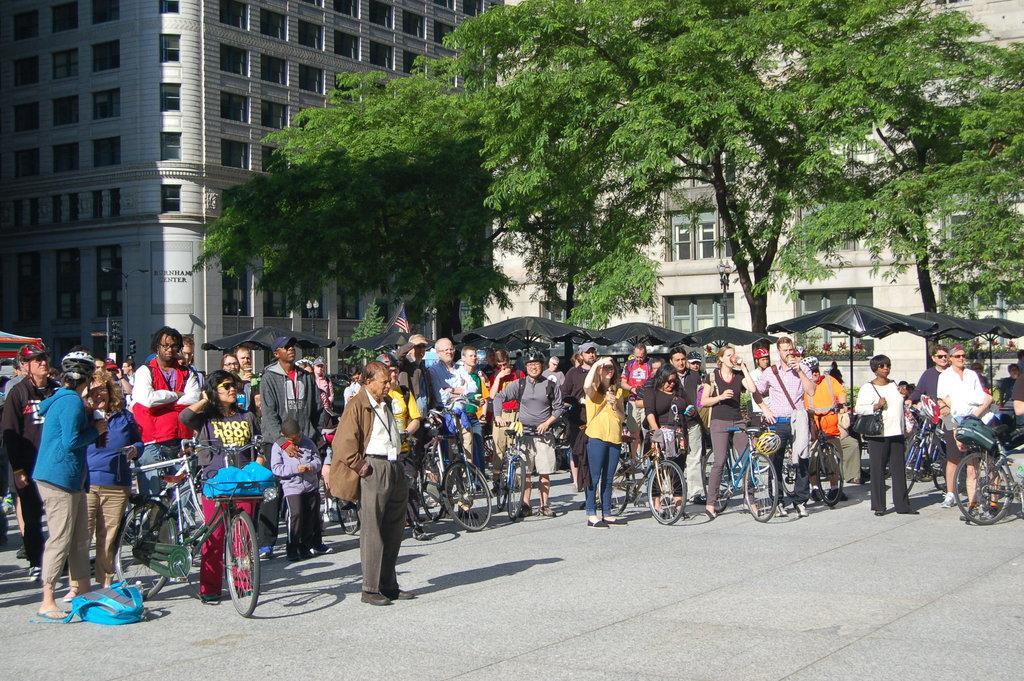In one or two sentences, can you explain what this image depicts? In the center of the image we can see a group of people are standing and few people are holding some objects and cycles. And we can see a few people are wearing caps and we can see a few other objects. In the background, we can see buildings, trees, tents, windows, traffic lights, poles etc.  